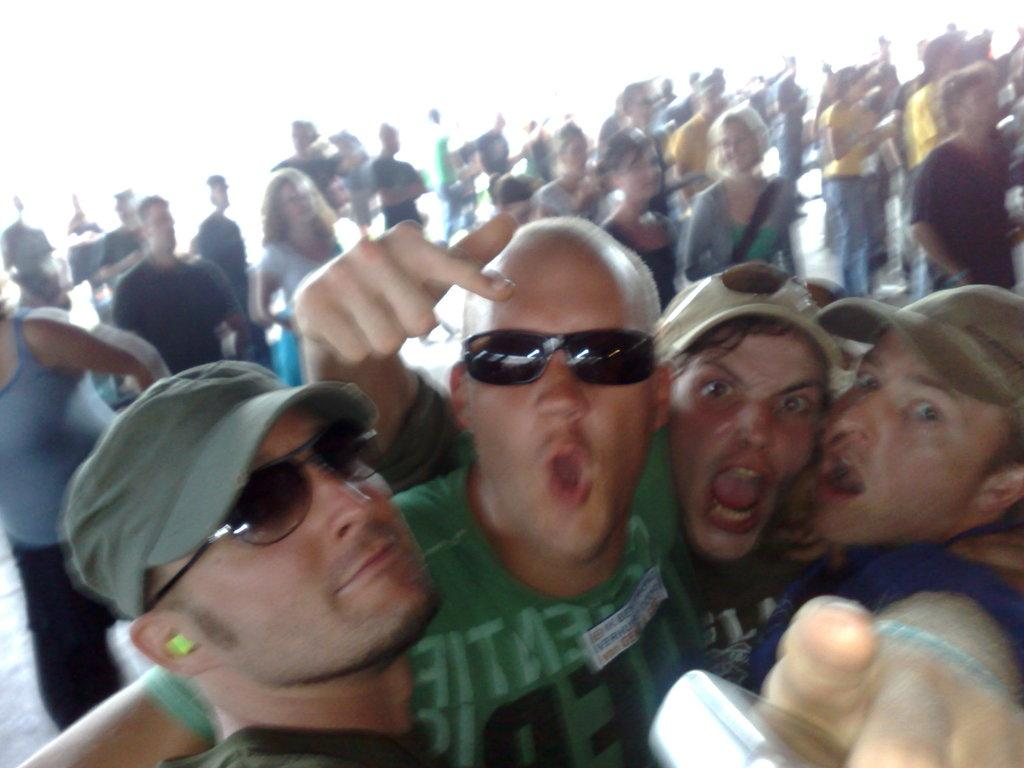How many people are in the image? There are many people in the image. What are the people in the image doing? The people are standing. What type of sack can be seen being used by the people in the image? There is no sack present in the image, and therefore no such activity can be observed. What color is the bulb that is being held by one of the people in the image? There is no bulb present in the image, and therefore no such activity can be observed. What type of chalk drawings can be seen on the ground in the image? There is no chalk or drawings present in the image, and therefore no such activity can be observed. 